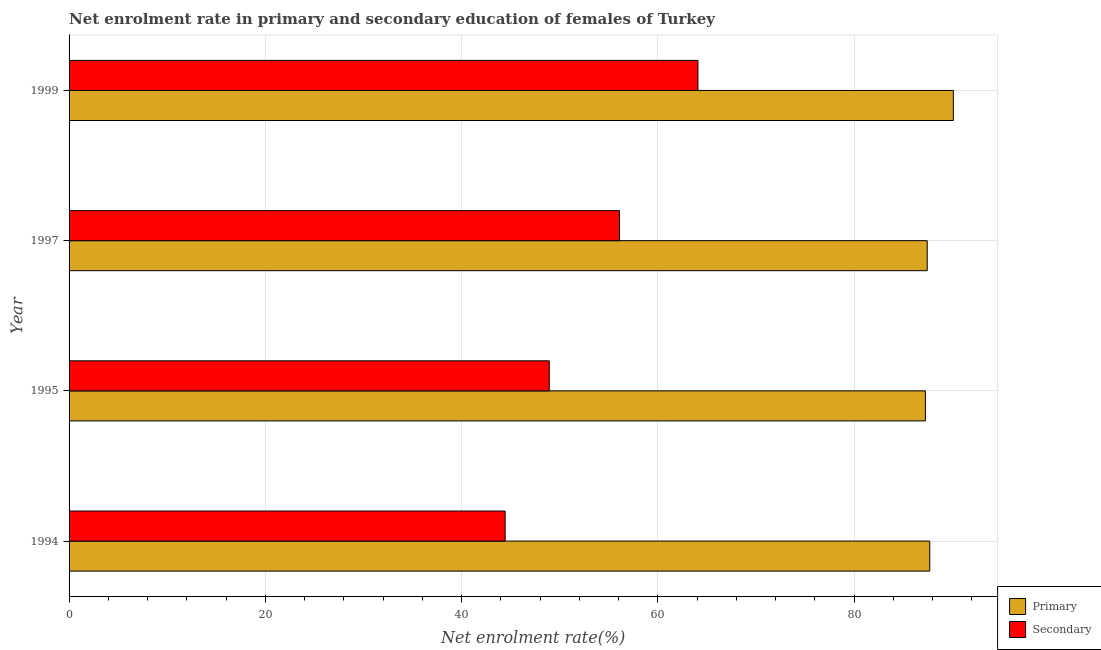How many bars are there on the 4th tick from the bottom?
Keep it short and to the point. 2. What is the label of the 3rd group of bars from the top?
Provide a succinct answer. 1995. What is the enrollment rate in secondary education in 1994?
Your response must be concise. 44.44. Across all years, what is the maximum enrollment rate in primary education?
Your answer should be very brief. 90.12. Across all years, what is the minimum enrollment rate in secondary education?
Make the answer very short. 44.44. In which year was the enrollment rate in secondary education minimum?
Keep it short and to the point. 1994. What is the total enrollment rate in primary education in the graph?
Provide a short and direct response. 352.56. What is the difference between the enrollment rate in primary education in 1994 and that in 1997?
Keep it short and to the point. 0.26. What is the difference between the enrollment rate in primary education in 1995 and the enrollment rate in secondary education in 1997?
Offer a very short reply. 31.18. What is the average enrollment rate in primary education per year?
Provide a succinct answer. 88.14. In the year 1999, what is the difference between the enrollment rate in primary education and enrollment rate in secondary education?
Your answer should be very brief. 26.03. What is the ratio of the enrollment rate in secondary education in 1997 to that in 1999?
Your answer should be compact. 0.88. What is the difference between the highest and the second highest enrollment rate in primary education?
Offer a very short reply. 2.41. What is the difference between the highest and the lowest enrollment rate in primary education?
Keep it short and to the point. 2.85. In how many years, is the enrollment rate in primary education greater than the average enrollment rate in primary education taken over all years?
Keep it short and to the point. 1. What does the 2nd bar from the top in 1995 represents?
Offer a very short reply. Primary. What does the 1st bar from the bottom in 1995 represents?
Make the answer very short. Primary. How many bars are there?
Offer a terse response. 8. Are all the bars in the graph horizontal?
Your answer should be compact. Yes. How many years are there in the graph?
Your answer should be very brief. 4. What is the difference between two consecutive major ticks on the X-axis?
Make the answer very short. 20. Does the graph contain grids?
Your answer should be very brief. Yes. Where does the legend appear in the graph?
Provide a short and direct response. Bottom right. How many legend labels are there?
Ensure brevity in your answer.  2. How are the legend labels stacked?
Your response must be concise. Vertical. What is the title of the graph?
Ensure brevity in your answer.  Net enrolment rate in primary and secondary education of females of Turkey. Does "Attending school" appear as one of the legend labels in the graph?
Your answer should be compact. No. What is the label or title of the X-axis?
Provide a succinct answer. Net enrolment rate(%). What is the Net enrolment rate(%) of Primary in 1994?
Offer a very short reply. 87.71. What is the Net enrolment rate(%) in Secondary in 1994?
Provide a succinct answer. 44.44. What is the Net enrolment rate(%) of Primary in 1995?
Your answer should be compact. 87.27. What is the Net enrolment rate(%) in Secondary in 1995?
Provide a short and direct response. 48.94. What is the Net enrolment rate(%) of Primary in 1997?
Offer a very short reply. 87.46. What is the Net enrolment rate(%) in Secondary in 1997?
Your answer should be very brief. 56.09. What is the Net enrolment rate(%) in Primary in 1999?
Your answer should be compact. 90.12. What is the Net enrolment rate(%) in Secondary in 1999?
Provide a succinct answer. 64.09. Across all years, what is the maximum Net enrolment rate(%) in Primary?
Your answer should be compact. 90.12. Across all years, what is the maximum Net enrolment rate(%) of Secondary?
Your response must be concise. 64.09. Across all years, what is the minimum Net enrolment rate(%) of Primary?
Provide a short and direct response. 87.27. Across all years, what is the minimum Net enrolment rate(%) of Secondary?
Provide a succinct answer. 44.44. What is the total Net enrolment rate(%) in Primary in the graph?
Give a very brief answer. 352.56. What is the total Net enrolment rate(%) of Secondary in the graph?
Provide a short and direct response. 213.57. What is the difference between the Net enrolment rate(%) in Primary in 1994 and that in 1995?
Give a very brief answer. 0.44. What is the difference between the Net enrolment rate(%) of Secondary in 1994 and that in 1995?
Your answer should be very brief. -4.49. What is the difference between the Net enrolment rate(%) in Primary in 1994 and that in 1997?
Offer a very short reply. 0.26. What is the difference between the Net enrolment rate(%) in Secondary in 1994 and that in 1997?
Give a very brief answer. -11.65. What is the difference between the Net enrolment rate(%) in Primary in 1994 and that in 1999?
Your answer should be very brief. -2.41. What is the difference between the Net enrolment rate(%) of Secondary in 1994 and that in 1999?
Your answer should be very brief. -19.65. What is the difference between the Net enrolment rate(%) of Primary in 1995 and that in 1997?
Make the answer very short. -0.18. What is the difference between the Net enrolment rate(%) in Secondary in 1995 and that in 1997?
Provide a succinct answer. -7.16. What is the difference between the Net enrolment rate(%) of Primary in 1995 and that in 1999?
Provide a succinct answer. -2.85. What is the difference between the Net enrolment rate(%) of Secondary in 1995 and that in 1999?
Your answer should be compact. -15.15. What is the difference between the Net enrolment rate(%) of Primary in 1997 and that in 1999?
Provide a succinct answer. -2.66. What is the difference between the Net enrolment rate(%) of Secondary in 1997 and that in 1999?
Provide a succinct answer. -8. What is the difference between the Net enrolment rate(%) of Primary in 1994 and the Net enrolment rate(%) of Secondary in 1995?
Give a very brief answer. 38.78. What is the difference between the Net enrolment rate(%) of Primary in 1994 and the Net enrolment rate(%) of Secondary in 1997?
Your response must be concise. 31.62. What is the difference between the Net enrolment rate(%) of Primary in 1994 and the Net enrolment rate(%) of Secondary in 1999?
Offer a very short reply. 23.62. What is the difference between the Net enrolment rate(%) in Primary in 1995 and the Net enrolment rate(%) in Secondary in 1997?
Provide a short and direct response. 31.18. What is the difference between the Net enrolment rate(%) of Primary in 1995 and the Net enrolment rate(%) of Secondary in 1999?
Keep it short and to the point. 23.18. What is the difference between the Net enrolment rate(%) of Primary in 1997 and the Net enrolment rate(%) of Secondary in 1999?
Your answer should be compact. 23.36. What is the average Net enrolment rate(%) of Primary per year?
Offer a very short reply. 88.14. What is the average Net enrolment rate(%) of Secondary per year?
Keep it short and to the point. 53.39. In the year 1994, what is the difference between the Net enrolment rate(%) of Primary and Net enrolment rate(%) of Secondary?
Provide a succinct answer. 43.27. In the year 1995, what is the difference between the Net enrolment rate(%) of Primary and Net enrolment rate(%) of Secondary?
Your answer should be compact. 38.33. In the year 1997, what is the difference between the Net enrolment rate(%) in Primary and Net enrolment rate(%) in Secondary?
Your response must be concise. 31.36. In the year 1999, what is the difference between the Net enrolment rate(%) of Primary and Net enrolment rate(%) of Secondary?
Ensure brevity in your answer.  26.03. What is the ratio of the Net enrolment rate(%) of Secondary in 1994 to that in 1995?
Your answer should be very brief. 0.91. What is the ratio of the Net enrolment rate(%) in Secondary in 1994 to that in 1997?
Offer a very short reply. 0.79. What is the ratio of the Net enrolment rate(%) of Primary in 1994 to that in 1999?
Your response must be concise. 0.97. What is the ratio of the Net enrolment rate(%) in Secondary in 1994 to that in 1999?
Give a very brief answer. 0.69. What is the ratio of the Net enrolment rate(%) of Secondary in 1995 to that in 1997?
Provide a succinct answer. 0.87. What is the ratio of the Net enrolment rate(%) in Primary in 1995 to that in 1999?
Provide a succinct answer. 0.97. What is the ratio of the Net enrolment rate(%) of Secondary in 1995 to that in 1999?
Offer a very short reply. 0.76. What is the ratio of the Net enrolment rate(%) in Primary in 1997 to that in 1999?
Provide a short and direct response. 0.97. What is the ratio of the Net enrolment rate(%) of Secondary in 1997 to that in 1999?
Your response must be concise. 0.88. What is the difference between the highest and the second highest Net enrolment rate(%) in Primary?
Offer a terse response. 2.41. What is the difference between the highest and the second highest Net enrolment rate(%) of Secondary?
Provide a succinct answer. 8. What is the difference between the highest and the lowest Net enrolment rate(%) of Primary?
Provide a short and direct response. 2.85. What is the difference between the highest and the lowest Net enrolment rate(%) of Secondary?
Ensure brevity in your answer.  19.65. 